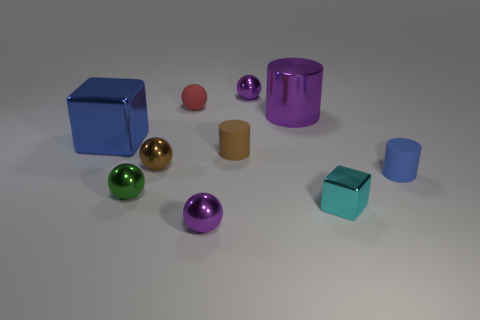There is a metallic cylinder; is its color the same as the object in front of the tiny cyan shiny thing?
Give a very brief answer. Yes. There is a tiny shiny thing behind the small red rubber object; does it have the same color as the big metallic cylinder?
Your response must be concise. Yes. How many objects are big metallic blocks or tiny balls behind the small red matte object?
Your response must be concise. 2. The small sphere that is in front of the tiny red matte thing and to the right of the brown metallic thing is made of what material?
Keep it short and to the point. Metal. There is a tiny brown thing behind the brown metallic sphere; what is it made of?
Give a very brief answer. Rubber. What color is the large block that is made of the same material as the big purple object?
Your response must be concise. Blue. Is the shape of the cyan object the same as the tiny purple metal thing behind the blue cylinder?
Provide a succinct answer. No. There is a cyan object; are there any purple things in front of it?
Offer a very short reply. Yes. There is a tiny cylinder that is the same color as the big shiny cube; what is its material?
Give a very brief answer. Rubber. There is a brown rubber thing; is it the same size as the shiny cube that is behind the cyan cube?
Keep it short and to the point. No. 